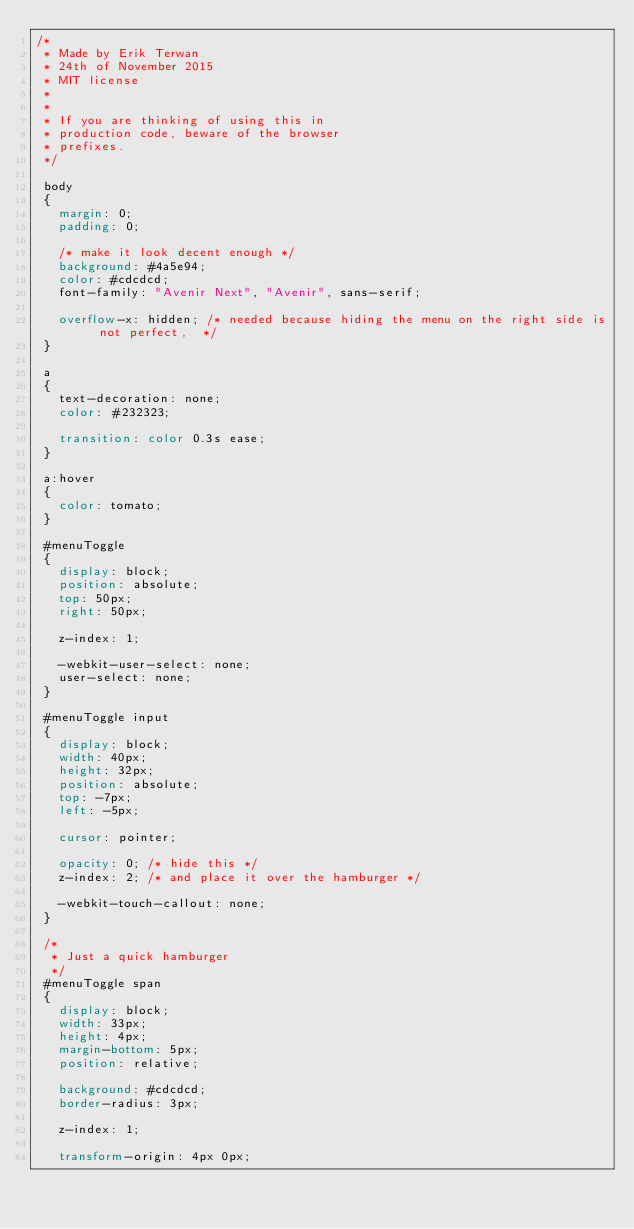Convert code to text. <code><loc_0><loc_0><loc_500><loc_500><_CSS_>/*
 * Made by Erik Terwan
 * 24th of November 2015
 * MIT license
 *
 *
 * If you are thinking of using this in
 * production code, beware of the browser
 * prefixes.
 */

 body
 {
   margin: 0;
   padding: 0;
   
   /* make it look decent enough */
   background: #4a5e94;
   color: #cdcdcd;
   font-family: "Avenir Next", "Avenir", sans-serif;
   
   overflow-x: hidden; /* needed because hiding the menu on the right side is not perfect,  */
 }
 
 a
 {
   text-decoration: none;
   color: #232323;
   
   transition: color 0.3s ease;
 }
 
 a:hover
 {
   color: tomato;
 }
 
 #menuToggle
 {
   display: block;
   position: absolute;
   top: 50px;
   right: 50px;
   
   z-index: 1;
   
   -webkit-user-select: none;
   user-select: none;
 }
 
 #menuToggle input
 {
   display: block;
   width: 40px;
   height: 32px;
   position: absolute;
   top: -7px;
   left: -5px;
   
   cursor: pointer;
   
   opacity: 0; /* hide this */
   z-index: 2; /* and place it over the hamburger */
   
   -webkit-touch-callout: none;
 }
 
 /*
  * Just a quick hamburger
  */
 #menuToggle span
 {
   display: block;
   width: 33px;
   height: 4px;
   margin-bottom: 5px;
   position: relative;
   
   background: #cdcdcd;
   border-radius: 3px;
   
   z-index: 1;
   
   transform-origin: 4px 0px;
   </code> 